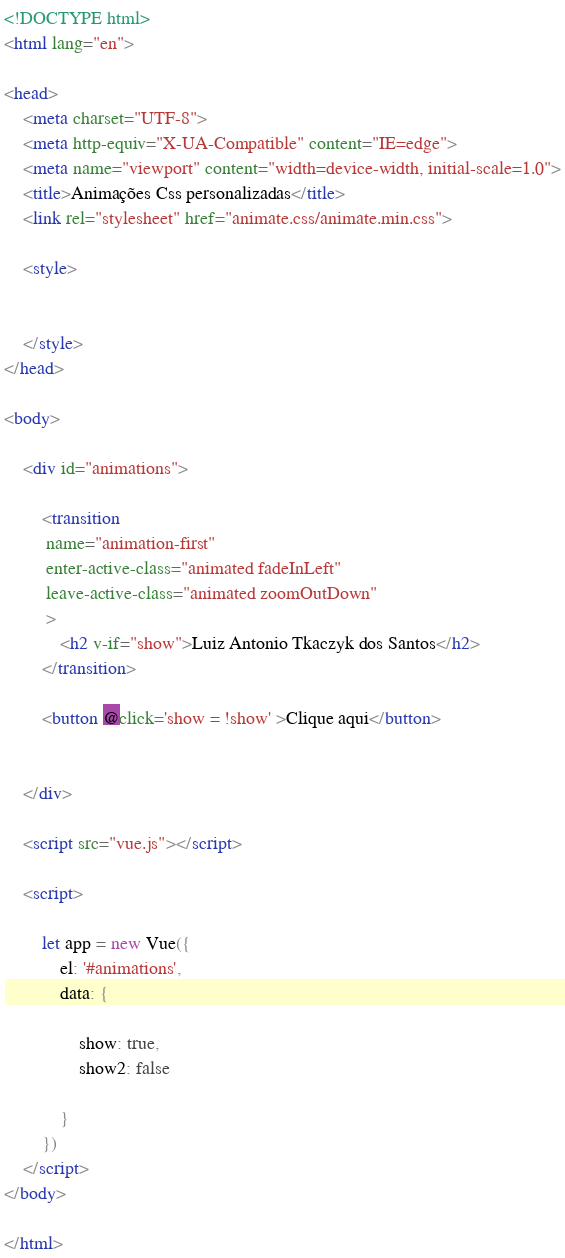Convert code to text. <code><loc_0><loc_0><loc_500><loc_500><_HTML_><!DOCTYPE html>
<html lang="en">

<head>
    <meta charset="UTF-8">
    <meta http-equiv="X-UA-Compatible" content="IE=edge">
    <meta name="viewport" content="width=device-width, initial-scale=1.0">
    <title>Animações Css personalizadas</title>
    <link rel="stylesheet" href="animate.css/animate.min.css">

    <style>
        
        
    </style>
</head>

<body>

    <div id="animations">

        <transition
         name="animation-first"
         enter-active-class="animated fadeInLeft"
         leave-active-class="animated zoomOutDown"
         >
            <h2 v-if="show">Luiz Antonio Tkaczyk dos Santos</h2>
        </transition>

        <button @click='show = !show' >Clique aqui</button>

      
    </div>

    <script src="vue.js"></script>

    <script>

        let app = new Vue({
            el: '#animations',
            data: {

                show: true,
                show2: false

            }
        })
    </script>
</body>

</html></code> 